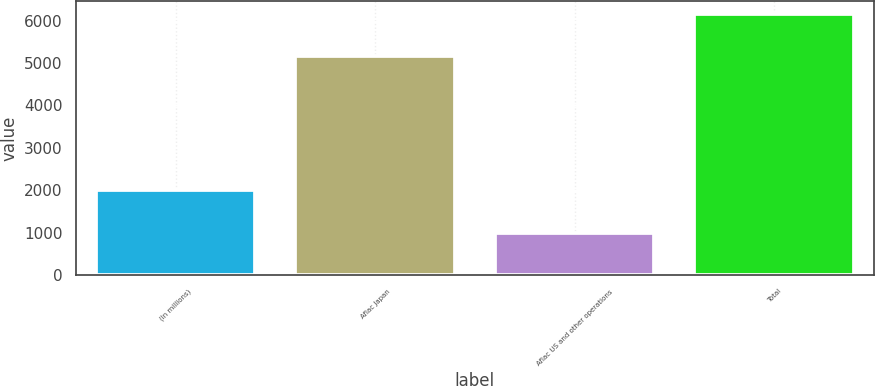<chart> <loc_0><loc_0><loc_500><loc_500><bar_chart><fcel>(In millions)<fcel>Aflac Japan<fcel>Aflac US and other operations<fcel>Total<nl><fcel>2009<fcel>5177<fcel>984<fcel>6161<nl></chart> 